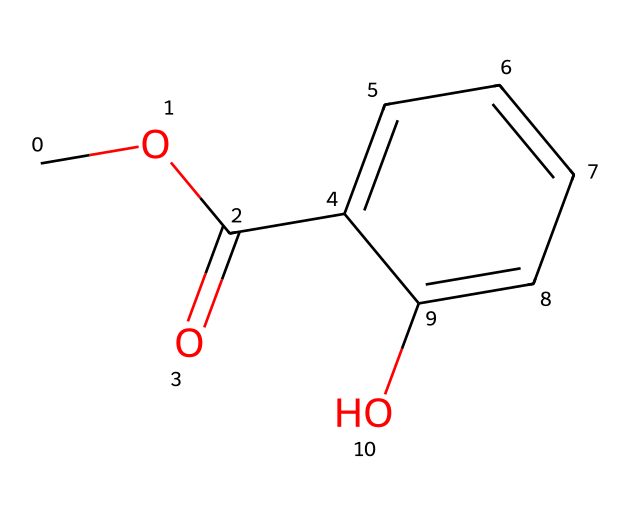What is the molecular formula of methyl salicylate? By analyzing the SMILES representation, we can determine the individual atoms present. Counting the carbon (C), hydrogen (H), and oxygen (O) atoms gives a total of 9 carbons, 10 hydrogens, and 3 oxygens, resulting in the molecular formula C9H10O3.
Answer: C9H10O3 How many rings are present in methyl salicylate? Inspecting the chemical structure, we can identify that there is one cyclic structure in the compound, which is the aromatic ring (the six-membered carbon ring).
Answer: 1 What functional group defines methyl salicylate as an ester? The presence of the carbonyl (C=O) and ether (C-O-C) linkages in its structure identifies it as an ester, as esters are characterized by the presence of a carbonyl adjacent to an ether.
Answer: ester How many double bonds are present in the structure of methyl salicylate? Looking at the SMILES representation, we see one carbonyl group (C=O) and another double bond within the aromatic ring, summing up to two double bonds in total.
Answer: 2 Which part of the molecule is responsible for its aroma? The aromatic ring (C1=CC=CC=C1), which is part of the overall structure, contributes to the distinctive wintergreen scent characteristic of methyl salicylate.
Answer: aromatic ring What is the primary use of methyl salicylate in natural remedies? Methyl salicylate is primarily used for its analgesic properties, often applied topically for muscle and joint pain relief in various medicinal treatments.
Answer: analgesic properties 